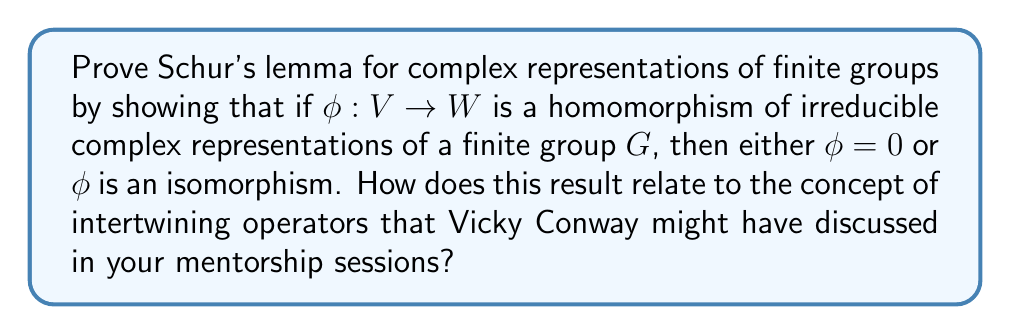Help me with this question. Let's prove Schur's lemma step by step:

1) First, consider $\ker(\phi)$. Since $\phi$ is a homomorphism of representations, $\ker(\phi)$ is a $G$-invariant subspace of $V$.

2) As $V$ is irreducible, it has only two $G$-invariant subspaces: $\{0\}$ and $V$ itself.

3) If $\ker(\phi) = V$, then $\phi = 0$.

4) If $\ker(\phi) = \{0\}$, then $\phi$ is injective.

5) Now consider $\text{im}(\phi)$. It's a $G$-invariant subspace of $W$.

6) As $W$ is irreducible, $\text{im}(\phi)$ must be either $\{0\}$ or $W$.

7) If $\text{im}(\phi) = \{0\}$, then $\phi = 0$.

8) If $\text{im}(\phi) = W$, then $\phi$ is surjective.

9) Combining the results from steps 4 and 8, if $\phi \neq 0$, then $\phi$ is both injective and surjective, hence an isomorphism.

This result relates to intertwining operators as follows:

10) An intertwining operator between two representations is precisely a homomorphism of representations.

11) Schur's lemma thus characterizes the intertwining operators between irreducible representations: they are either zero or isomorphisms.

12) This implies that the only intertwining operators from an irreducible representation to itself are scalar multiples of the identity (as these are the only isomorphisms from a vector space to itself that commute with all operators).
Answer: $\phi = 0$ or $\phi$ is an isomorphism. Relates to intertwining operators: only scalar multiples of identity for irreducible self-maps. 